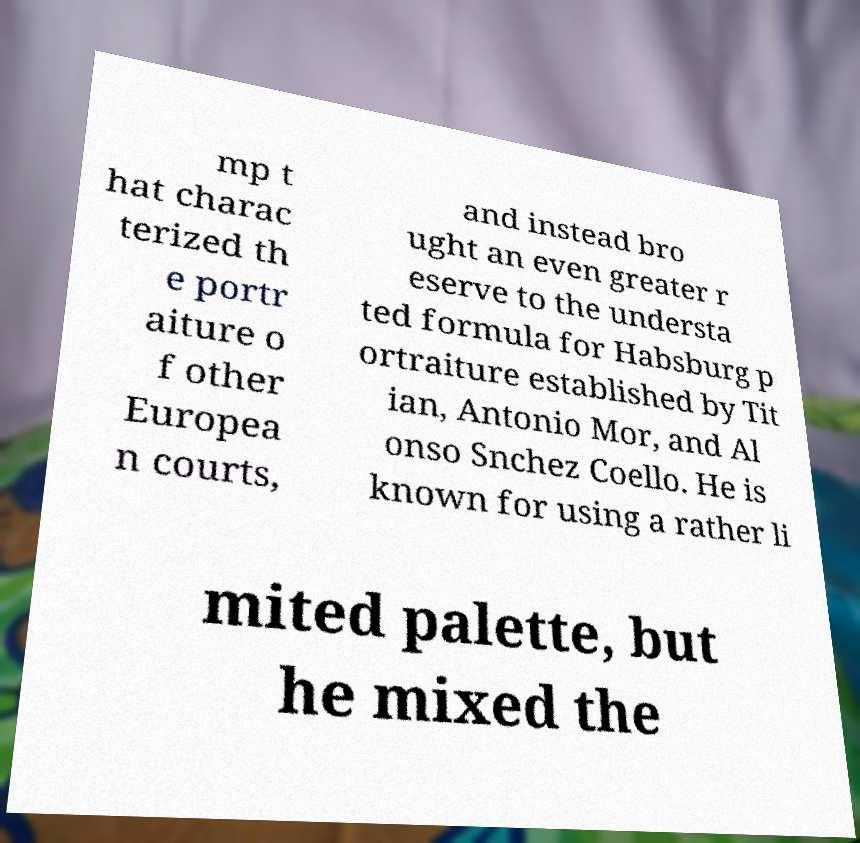Can you accurately transcribe the text from the provided image for me? mp t hat charac terized th e portr aiture o f other Europea n courts, and instead bro ught an even greater r eserve to the understa ted formula for Habsburg p ortraiture established by Tit ian, Antonio Mor, and Al onso Snchez Coello. He is known for using a rather li mited palette, but he mixed the 